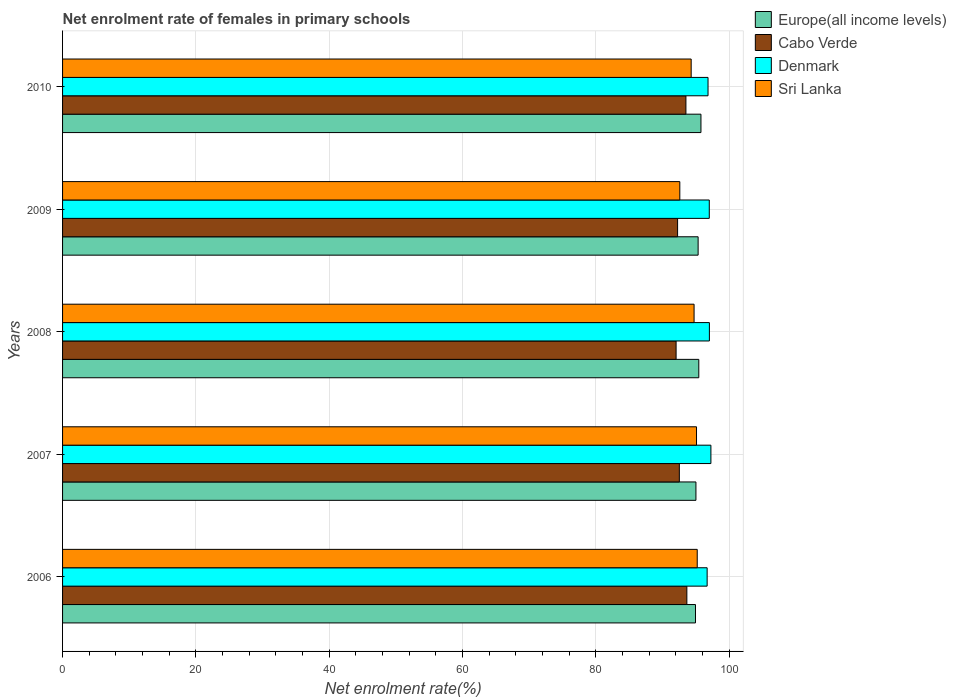Are the number of bars per tick equal to the number of legend labels?
Offer a very short reply. Yes. In how many cases, is the number of bars for a given year not equal to the number of legend labels?
Give a very brief answer. 0. What is the net enrolment rate of females in primary schools in Denmark in 2007?
Make the answer very short. 97.27. Across all years, what is the maximum net enrolment rate of females in primary schools in Sri Lanka?
Offer a terse response. 95.22. Across all years, what is the minimum net enrolment rate of females in primary schools in Sri Lanka?
Provide a succinct answer. 92.61. In which year was the net enrolment rate of females in primary schools in Denmark maximum?
Provide a short and direct response. 2007. What is the total net enrolment rate of females in primary schools in Europe(all income levels) in the graph?
Make the answer very short. 476.56. What is the difference between the net enrolment rate of females in primary schools in Europe(all income levels) in 2008 and that in 2010?
Offer a very short reply. -0.32. What is the difference between the net enrolment rate of females in primary schools in Europe(all income levels) in 2006 and the net enrolment rate of females in primary schools in Denmark in 2010?
Offer a terse response. -1.88. What is the average net enrolment rate of females in primary schools in Europe(all income levels) per year?
Your response must be concise. 95.31. In the year 2006, what is the difference between the net enrolment rate of females in primary schools in Denmark and net enrolment rate of females in primary schools in Sri Lanka?
Your answer should be very brief. 1.49. What is the ratio of the net enrolment rate of females in primary schools in Sri Lanka in 2006 to that in 2008?
Keep it short and to the point. 1.01. Is the net enrolment rate of females in primary schools in Europe(all income levels) in 2007 less than that in 2009?
Your answer should be compact. Yes. What is the difference between the highest and the second highest net enrolment rate of females in primary schools in Europe(all income levels)?
Keep it short and to the point. 0.32. What is the difference between the highest and the lowest net enrolment rate of females in primary schools in Sri Lanka?
Offer a terse response. 2.61. Is the sum of the net enrolment rate of females in primary schools in Denmark in 2006 and 2010 greater than the maximum net enrolment rate of females in primary schools in Europe(all income levels) across all years?
Ensure brevity in your answer.  Yes. What does the 2nd bar from the top in 2006 represents?
Ensure brevity in your answer.  Denmark. What does the 3rd bar from the bottom in 2008 represents?
Give a very brief answer. Denmark. Is it the case that in every year, the sum of the net enrolment rate of females in primary schools in Sri Lanka and net enrolment rate of females in primary schools in Cabo Verde is greater than the net enrolment rate of females in primary schools in Europe(all income levels)?
Ensure brevity in your answer.  Yes. How many years are there in the graph?
Make the answer very short. 5. How many legend labels are there?
Keep it short and to the point. 4. What is the title of the graph?
Provide a short and direct response. Net enrolment rate of females in primary schools. What is the label or title of the X-axis?
Keep it short and to the point. Net enrolment rate(%). What is the Net enrolment rate(%) in Europe(all income levels) in 2006?
Provide a succinct answer. 94.96. What is the Net enrolment rate(%) of Cabo Verde in 2006?
Ensure brevity in your answer.  93.66. What is the Net enrolment rate(%) in Denmark in 2006?
Provide a succinct answer. 96.71. What is the Net enrolment rate(%) in Sri Lanka in 2006?
Offer a terse response. 95.22. What is the Net enrolment rate(%) of Europe(all income levels) in 2007?
Your answer should be compact. 95.02. What is the Net enrolment rate(%) in Cabo Verde in 2007?
Make the answer very short. 92.53. What is the Net enrolment rate(%) in Denmark in 2007?
Your answer should be compact. 97.27. What is the Net enrolment rate(%) in Sri Lanka in 2007?
Your response must be concise. 95.11. What is the Net enrolment rate(%) in Europe(all income levels) in 2008?
Provide a short and direct response. 95.45. What is the Net enrolment rate(%) of Cabo Verde in 2008?
Your answer should be very brief. 92.05. What is the Net enrolment rate(%) in Denmark in 2008?
Your answer should be very brief. 97.04. What is the Net enrolment rate(%) of Sri Lanka in 2008?
Provide a short and direct response. 94.74. What is the Net enrolment rate(%) in Europe(all income levels) in 2009?
Your response must be concise. 95.35. What is the Net enrolment rate(%) of Cabo Verde in 2009?
Your answer should be very brief. 92.27. What is the Net enrolment rate(%) of Denmark in 2009?
Your response must be concise. 97.03. What is the Net enrolment rate(%) in Sri Lanka in 2009?
Offer a terse response. 92.61. What is the Net enrolment rate(%) in Europe(all income levels) in 2010?
Offer a terse response. 95.78. What is the Net enrolment rate(%) of Cabo Verde in 2010?
Ensure brevity in your answer.  93.52. What is the Net enrolment rate(%) of Denmark in 2010?
Offer a terse response. 96.84. What is the Net enrolment rate(%) in Sri Lanka in 2010?
Your answer should be compact. 94.31. Across all years, what is the maximum Net enrolment rate(%) of Europe(all income levels)?
Provide a short and direct response. 95.78. Across all years, what is the maximum Net enrolment rate(%) in Cabo Verde?
Make the answer very short. 93.66. Across all years, what is the maximum Net enrolment rate(%) of Denmark?
Your answer should be compact. 97.27. Across all years, what is the maximum Net enrolment rate(%) in Sri Lanka?
Offer a very short reply. 95.22. Across all years, what is the minimum Net enrolment rate(%) of Europe(all income levels)?
Keep it short and to the point. 94.96. Across all years, what is the minimum Net enrolment rate(%) of Cabo Verde?
Offer a terse response. 92.05. Across all years, what is the minimum Net enrolment rate(%) in Denmark?
Your answer should be compact. 96.71. Across all years, what is the minimum Net enrolment rate(%) in Sri Lanka?
Give a very brief answer. 92.61. What is the total Net enrolment rate(%) of Europe(all income levels) in the graph?
Provide a succinct answer. 476.56. What is the total Net enrolment rate(%) of Cabo Verde in the graph?
Offer a very short reply. 464.04. What is the total Net enrolment rate(%) in Denmark in the graph?
Offer a terse response. 484.89. What is the total Net enrolment rate(%) of Sri Lanka in the graph?
Give a very brief answer. 471.99. What is the difference between the Net enrolment rate(%) of Europe(all income levels) in 2006 and that in 2007?
Provide a short and direct response. -0.07. What is the difference between the Net enrolment rate(%) of Cabo Verde in 2006 and that in 2007?
Provide a short and direct response. 1.13. What is the difference between the Net enrolment rate(%) in Denmark in 2006 and that in 2007?
Your answer should be very brief. -0.56. What is the difference between the Net enrolment rate(%) of Sri Lanka in 2006 and that in 2007?
Give a very brief answer. 0.11. What is the difference between the Net enrolment rate(%) in Europe(all income levels) in 2006 and that in 2008?
Your response must be concise. -0.5. What is the difference between the Net enrolment rate(%) in Cabo Verde in 2006 and that in 2008?
Your answer should be very brief. 1.61. What is the difference between the Net enrolment rate(%) of Denmark in 2006 and that in 2008?
Offer a terse response. -0.34. What is the difference between the Net enrolment rate(%) of Sri Lanka in 2006 and that in 2008?
Provide a short and direct response. 0.47. What is the difference between the Net enrolment rate(%) in Europe(all income levels) in 2006 and that in 2009?
Give a very brief answer. -0.4. What is the difference between the Net enrolment rate(%) of Cabo Verde in 2006 and that in 2009?
Your answer should be compact. 1.39. What is the difference between the Net enrolment rate(%) of Denmark in 2006 and that in 2009?
Your answer should be compact. -0.32. What is the difference between the Net enrolment rate(%) in Sri Lanka in 2006 and that in 2009?
Provide a short and direct response. 2.61. What is the difference between the Net enrolment rate(%) in Europe(all income levels) in 2006 and that in 2010?
Make the answer very short. -0.82. What is the difference between the Net enrolment rate(%) of Cabo Verde in 2006 and that in 2010?
Keep it short and to the point. 0.14. What is the difference between the Net enrolment rate(%) of Denmark in 2006 and that in 2010?
Make the answer very short. -0.13. What is the difference between the Net enrolment rate(%) in Sri Lanka in 2006 and that in 2010?
Your answer should be very brief. 0.91. What is the difference between the Net enrolment rate(%) in Europe(all income levels) in 2007 and that in 2008?
Your answer should be compact. -0.43. What is the difference between the Net enrolment rate(%) of Cabo Verde in 2007 and that in 2008?
Ensure brevity in your answer.  0.49. What is the difference between the Net enrolment rate(%) in Denmark in 2007 and that in 2008?
Offer a very short reply. 0.23. What is the difference between the Net enrolment rate(%) in Sri Lanka in 2007 and that in 2008?
Your answer should be very brief. 0.37. What is the difference between the Net enrolment rate(%) of Europe(all income levels) in 2007 and that in 2009?
Your answer should be compact. -0.33. What is the difference between the Net enrolment rate(%) of Cabo Verde in 2007 and that in 2009?
Your answer should be compact. 0.26. What is the difference between the Net enrolment rate(%) in Denmark in 2007 and that in 2009?
Give a very brief answer. 0.24. What is the difference between the Net enrolment rate(%) in Sri Lanka in 2007 and that in 2009?
Offer a terse response. 2.5. What is the difference between the Net enrolment rate(%) in Europe(all income levels) in 2007 and that in 2010?
Give a very brief answer. -0.75. What is the difference between the Net enrolment rate(%) in Cabo Verde in 2007 and that in 2010?
Your answer should be compact. -0.99. What is the difference between the Net enrolment rate(%) of Denmark in 2007 and that in 2010?
Your response must be concise. 0.43. What is the difference between the Net enrolment rate(%) of Sri Lanka in 2007 and that in 2010?
Offer a terse response. 0.8. What is the difference between the Net enrolment rate(%) of Europe(all income levels) in 2008 and that in 2009?
Provide a succinct answer. 0.1. What is the difference between the Net enrolment rate(%) of Cabo Verde in 2008 and that in 2009?
Ensure brevity in your answer.  -0.23. What is the difference between the Net enrolment rate(%) in Denmark in 2008 and that in 2009?
Provide a short and direct response. 0.02. What is the difference between the Net enrolment rate(%) of Sri Lanka in 2008 and that in 2009?
Ensure brevity in your answer.  2.14. What is the difference between the Net enrolment rate(%) in Europe(all income levels) in 2008 and that in 2010?
Give a very brief answer. -0.32. What is the difference between the Net enrolment rate(%) in Cabo Verde in 2008 and that in 2010?
Give a very brief answer. -1.47. What is the difference between the Net enrolment rate(%) in Denmark in 2008 and that in 2010?
Provide a short and direct response. 0.21. What is the difference between the Net enrolment rate(%) in Sri Lanka in 2008 and that in 2010?
Your answer should be very brief. 0.44. What is the difference between the Net enrolment rate(%) of Europe(all income levels) in 2009 and that in 2010?
Your answer should be very brief. -0.42. What is the difference between the Net enrolment rate(%) in Cabo Verde in 2009 and that in 2010?
Provide a succinct answer. -1.25. What is the difference between the Net enrolment rate(%) of Denmark in 2009 and that in 2010?
Make the answer very short. 0.19. What is the difference between the Net enrolment rate(%) in Sri Lanka in 2009 and that in 2010?
Offer a terse response. -1.7. What is the difference between the Net enrolment rate(%) in Europe(all income levels) in 2006 and the Net enrolment rate(%) in Cabo Verde in 2007?
Ensure brevity in your answer.  2.42. What is the difference between the Net enrolment rate(%) of Europe(all income levels) in 2006 and the Net enrolment rate(%) of Denmark in 2007?
Give a very brief answer. -2.31. What is the difference between the Net enrolment rate(%) of Europe(all income levels) in 2006 and the Net enrolment rate(%) of Sri Lanka in 2007?
Your answer should be very brief. -0.15. What is the difference between the Net enrolment rate(%) of Cabo Verde in 2006 and the Net enrolment rate(%) of Denmark in 2007?
Offer a very short reply. -3.61. What is the difference between the Net enrolment rate(%) of Cabo Verde in 2006 and the Net enrolment rate(%) of Sri Lanka in 2007?
Provide a short and direct response. -1.45. What is the difference between the Net enrolment rate(%) of Denmark in 2006 and the Net enrolment rate(%) of Sri Lanka in 2007?
Your response must be concise. 1.6. What is the difference between the Net enrolment rate(%) of Europe(all income levels) in 2006 and the Net enrolment rate(%) of Cabo Verde in 2008?
Your answer should be compact. 2.91. What is the difference between the Net enrolment rate(%) of Europe(all income levels) in 2006 and the Net enrolment rate(%) of Denmark in 2008?
Offer a very short reply. -2.09. What is the difference between the Net enrolment rate(%) of Europe(all income levels) in 2006 and the Net enrolment rate(%) of Sri Lanka in 2008?
Provide a short and direct response. 0.21. What is the difference between the Net enrolment rate(%) of Cabo Verde in 2006 and the Net enrolment rate(%) of Denmark in 2008?
Keep it short and to the point. -3.38. What is the difference between the Net enrolment rate(%) of Cabo Verde in 2006 and the Net enrolment rate(%) of Sri Lanka in 2008?
Give a very brief answer. -1.08. What is the difference between the Net enrolment rate(%) in Denmark in 2006 and the Net enrolment rate(%) in Sri Lanka in 2008?
Make the answer very short. 1.96. What is the difference between the Net enrolment rate(%) of Europe(all income levels) in 2006 and the Net enrolment rate(%) of Cabo Verde in 2009?
Offer a terse response. 2.68. What is the difference between the Net enrolment rate(%) in Europe(all income levels) in 2006 and the Net enrolment rate(%) in Denmark in 2009?
Ensure brevity in your answer.  -2.07. What is the difference between the Net enrolment rate(%) in Europe(all income levels) in 2006 and the Net enrolment rate(%) in Sri Lanka in 2009?
Your answer should be very brief. 2.35. What is the difference between the Net enrolment rate(%) of Cabo Verde in 2006 and the Net enrolment rate(%) of Denmark in 2009?
Offer a very short reply. -3.36. What is the difference between the Net enrolment rate(%) in Cabo Verde in 2006 and the Net enrolment rate(%) in Sri Lanka in 2009?
Your response must be concise. 1.06. What is the difference between the Net enrolment rate(%) in Denmark in 2006 and the Net enrolment rate(%) in Sri Lanka in 2009?
Ensure brevity in your answer.  4.1. What is the difference between the Net enrolment rate(%) in Europe(all income levels) in 2006 and the Net enrolment rate(%) in Cabo Verde in 2010?
Make the answer very short. 1.43. What is the difference between the Net enrolment rate(%) of Europe(all income levels) in 2006 and the Net enrolment rate(%) of Denmark in 2010?
Provide a short and direct response. -1.88. What is the difference between the Net enrolment rate(%) of Europe(all income levels) in 2006 and the Net enrolment rate(%) of Sri Lanka in 2010?
Provide a short and direct response. 0.65. What is the difference between the Net enrolment rate(%) in Cabo Verde in 2006 and the Net enrolment rate(%) in Denmark in 2010?
Ensure brevity in your answer.  -3.18. What is the difference between the Net enrolment rate(%) in Cabo Verde in 2006 and the Net enrolment rate(%) in Sri Lanka in 2010?
Your response must be concise. -0.65. What is the difference between the Net enrolment rate(%) in Denmark in 2006 and the Net enrolment rate(%) in Sri Lanka in 2010?
Offer a terse response. 2.4. What is the difference between the Net enrolment rate(%) in Europe(all income levels) in 2007 and the Net enrolment rate(%) in Cabo Verde in 2008?
Make the answer very short. 2.98. What is the difference between the Net enrolment rate(%) of Europe(all income levels) in 2007 and the Net enrolment rate(%) of Denmark in 2008?
Keep it short and to the point. -2.02. What is the difference between the Net enrolment rate(%) in Europe(all income levels) in 2007 and the Net enrolment rate(%) in Sri Lanka in 2008?
Offer a very short reply. 0.28. What is the difference between the Net enrolment rate(%) in Cabo Verde in 2007 and the Net enrolment rate(%) in Denmark in 2008?
Offer a terse response. -4.51. What is the difference between the Net enrolment rate(%) of Cabo Verde in 2007 and the Net enrolment rate(%) of Sri Lanka in 2008?
Offer a terse response. -2.21. What is the difference between the Net enrolment rate(%) in Denmark in 2007 and the Net enrolment rate(%) in Sri Lanka in 2008?
Make the answer very short. 2.53. What is the difference between the Net enrolment rate(%) of Europe(all income levels) in 2007 and the Net enrolment rate(%) of Cabo Verde in 2009?
Offer a terse response. 2.75. What is the difference between the Net enrolment rate(%) of Europe(all income levels) in 2007 and the Net enrolment rate(%) of Denmark in 2009?
Give a very brief answer. -2. What is the difference between the Net enrolment rate(%) of Europe(all income levels) in 2007 and the Net enrolment rate(%) of Sri Lanka in 2009?
Give a very brief answer. 2.42. What is the difference between the Net enrolment rate(%) in Cabo Verde in 2007 and the Net enrolment rate(%) in Denmark in 2009?
Your answer should be compact. -4.49. What is the difference between the Net enrolment rate(%) in Cabo Verde in 2007 and the Net enrolment rate(%) in Sri Lanka in 2009?
Offer a terse response. -0.07. What is the difference between the Net enrolment rate(%) of Denmark in 2007 and the Net enrolment rate(%) of Sri Lanka in 2009?
Make the answer very short. 4.66. What is the difference between the Net enrolment rate(%) in Europe(all income levels) in 2007 and the Net enrolment rate(%) in Cabo Verde in 2010?
Keep it short and to the point. 1.5. What is the difference between the Net enrolment rate(%) of Europe(all income levels) in 2007 and the Net enrolment rate(%) of Denmark in 2010?
Make the answer very short. -1.81. What is the difference between the Net enrolment rate(%) of Europe(all income levels) in 2007 and the Net enrolment rate(%) of Sri Lanka in 2010?
Provide a succinct answer. 0.71. What is the difference between the Net enrolment rate(%) of Cabo Verde in 2007 and the Net enrolment rate(%) of Denmark in 2010?
Make the answer very short. -4.3. What is the difference between the Net enrolment rate(%) in Cabo Verde in 2007 and the Net enrolment rate(%) in Sri Lanka in 2010?
Offer a very short reply. -1.77. What is the difference between the Net enrolment rate(%) in Denmark in 2007 and the Net enrolment rate(%) in Sri Lanka in 2010?
Provide a succinct answer. 2.96. What is the difference between the Net enrolment rate(%) of Europe(all income levels) in 2008 and the Net enrolment rate(%) of Cabo Verde in 2009?
Provide a succinct answer. 3.18. What is the difference between the Net enrolment rate(%) in Europe(all income levels) in 2008 and the Net enrolment rate(%) in Denmark in 2009?
Provide a short and direct response. -1.57. What is the difference between the Net enrolment rate(%) in Europe(all income levels) in 2008 and the Net enrolment rate(%) in Sri Lanka in 2009?
Make the answer very short. 2.85. What is the difference between the Net enrolment rate(%) in Cabo Verde in 2008 and the Net enrolment rate(%) in Denmark in 2009?
Your response must be concise. -4.98. What is the difference between the Net enrolment rate(%) of Cabo Verde in 2008 and the Net enrolment rate(%) of Sri Lanka in 2009?
Provide a succinct answer. -0.56. What is the difference between the Net enrolment rate(%) of Denmark in 2008 and the Net enrolment rate(%) of Sri Lanka in 2009?
Offer a terse response. 4.44. What is the difference between the Net enrolment rate(%) of Europe(all income levels) in 2008 and the Net enrolment rate(%) of Cabo Verde in 2010?
Your response must be concise. 1.93. What is the difference between the Net enrolment rate(%) in Europe(all income levels) in 2008 and the Net enrolment rate(%) in Denmark in 2010?
Offer a very short reply. -1.39. What is the difference between the Net enrolment rate(%) in Europe(all income levels) in 2008 and the Net enrolment rate(%) in Sri Lanka in 2010?
Your answer should be very brief. 1.14. What is the difference between the Net enrolment rate(%) in Cabo Verde in 2008 and the Net enrolment rate(%) in Denmark in 2010?
Your answer should be very brief. -4.79. What is the difference between the Net enrolment rate(%) of Cabo Verde in 2008 and the Net enrolment rate(%) of Sri Lanka in 2010?
Keep it short and to the point. -2.26. What is the difference between the Net enrolment rate(%) in Denmark in 2008 and the Net enrolment rate(%) in Sri Lanka in 2010?
Offer a terse response. 2.73. What is the difference between the Net enrolment rate(%) of Europe(all income levels) in 2009 and the Net enrolment rate(%) of Cabo Verde in 2010?
Ensure brevity in your answer.  1.83. What is the difference between the Net enrolment rate(%) of Europe(all income levels) in 2009 and the Net enrolment rate(%) of Denmark in 2010?
Make the answer very short. -1.49. What is the difference between the Net enrolment rate(%) of Europe(all income levels) in 2009 and the Net enrolment rate(%) of Sri Lanka in 2010?
Offer a terse response. 1.04. What is the difference between the Net enrolment rate(%) in Cabo Verde in 2009 and the Net enrolment rate(%) in Denmark in 2010?
Offer a terse response. -4.57. What is the difference between the Net enrolment rate(%) in Cabo Verde in 2009 and the Net enrolment rate(%) in Sri Lanka in 2010?
Give a very brief answer. -2.04. What is the difference between the Net enrolment rate(%) of Denmark in 2009 and the Net enrolment rate(%) of Sri Lanka in 2010?
Offer a very short reply. 2.72. What is the average Net enrolment rate(%) of Europe(all income levels) per year?
Your response must be concise. 95.31. What is the average Net enrolment rate(%) in Cabo Verde per year?
Provide a short and direct response. 92.81. What is the average Net enrolment rate(%) of Denmark per year?
Offer a very short reply. 96.98. What is the average Net enrolment rate(%) in Sri Lanka per year?
Provide a succinct answer. 94.4. In the year 2006, what is the difference between the Net enrolment rate(%) in Europe(all income levels) and Net enrolment rate(%) in Cabo Verde?
Your response must be concise. 1.29. In the year 2006, what is the difference between the Net enrolment rate(%) in Europe(all income levels) and Net enrolment rate(%) in Denmark?
Make the answer very short. -1.75. In the year 2006, what is the difference between the Net enrolment rate(%) in Europe(all income levels) and Net enrolment rate(%) in Sri Lanka?
Offer a terse response. -0.26. In the year 2006, what is the difference between the Net enrolment rate(%) in Cabo Verde and Net enrolment rate(%) in Denmark?
Offer a very short reply. -3.04. In the year 2006, what is the difference between the Net enrolment rate(%) of Cabo Verde and Net enrolment rate(%) of Sri Lanka?
Offer a very short reply. -1.56. In the year 2006, what is the difference between the Net enrolment rate(%) in Denmark and Net enrolment rate(%) in Sri Lanka?
Your answer should be very brief. 1.49. In the year 2007, what is the difference between the Net enrolment rate(%) of Europe(all income levels) and Net enrolment rate(%) of Cabo Verde?
Make the answer very short. 2.49. In the year 2007, what is the difference between the Net enrolment rate(%) of Europe(all income levels) and Net enrolment rate(%) of Denmark?
Offer a very short reply. -2.25. In the year 2007, what is the difference between the Net enrolment rate(%) in Europe(all income levels) and Net enrolment rate(%) in Sri Lanka?
Provide a succinct answer. -0.09. In the year 2007, what is the difference between the Net enrolment rate(%) in Cabo Verde and Net enrolment rate(%) in Denmark?
Make the answer very short. -4.74. In the year 2007, what is the difference between the Net enrolment rate(%) of Cabo Verde and Net enrolment rate(%) of Sri Lanka?
Keep it short and to the point. -2.58. In the year 2007, what is the difference between the Net enrolment rate(%) in Denmark and Net enrolment rate(%) in Sri Lanka?
Your response must be concise. 2.16. In the year 2008, what is the difference between the Net enrolment rate(%) of Europe(all income levels) and Net enrolment rate(%) of Cabo Verde?
Your answer should be compact. 3.41. In the year 2008, what is the difference between the Net enrolment rate(%) in Europe(all income levels) and Net enrolment rate(%) in Denmark?
Give a very brief answer. -1.59. In the year 2008, what is the difference between the Net enrolment rate(%) of Europe(all income levels) and Net enrolment rate(%) of Sri Lanka?
Offer a terse response. 0.71. In the year 2008, what is the difference between the Net enrolment rate(%) in Cabo Verde and Net enrolment rate(%) in Denmark?
Your answer should be very brief. -5. In the year 2008, what is the difference between the Net enrolment rate(%) of Cabo Verde and Net enrolment rate(%) of Sri Lanka?
Your response must be concise. -2.7. In the year 2008, what is the difference between the Net enrolment rate(%) in Denmark and Net enrolment rate(%) in Sri Lanka?
Ensure brevity in your answer.  2.3. In the year 2009, what is the difference between the Net enrolment rate(%) of Europe(all income levels) and Net enrolment rate(%) of Cabo Verde?
Keep it short and to the point. 3.08. In the year 2009, what is the difference between the Net enrolment rate(%) of Europe(all income levels) and Net enrolment rate(%) of Denmark?
Make the answer very short. -1.67. In the year 2009, what is the difference between the Net enrolment rate(%) in Europe(all income levels) and Net enrolment rate(%) in Sri Lanka?
Offer a terse response. 2.75. In the year 2009, what is the difference between the Net enrolment rate(%) of Cabo Verde and Net enrolment rate(%) of Denmark?
Your answer should be very brief. -4.75. In the year 2009, what is the difference between the Net enrolment rate(%) in Cabo Verde and Net enrolment rate(%) in Sri Lanka?
Your answer should be very brief. -0.33. In the year 2009, what is the difference between the Net enrolment rate(%) in Denmark and Net enrolment rate(%) in Sri Lanka?
Your answer should be compact. 4.42. In the year 2010, what is the difference between the Net enrolment rate(%) in Europe(all income levels) and Net enrolment rate(%) in Cabo Verde?
Keep it short and to the point. 2.25. In the year 2010, what is the difference between the Net enrolment rate(%) of Europe(all income levels) and Net enrolment rate(%) of Denmark?
Offer a very short reply. -1.06. In the year 2010, what is the difference between the Net enrolment rate(%) in Europe(all income levels) and Net enrolment rate(%) in Sri Lanka?
Provide a succinct answer. 1.47. In the year 2010, what is the difference between the Net enrolment rate(%) of Cabo Verde and Net enrolment rate(%) of Denmark?
Offer a very short reply. -3.32. In the year 2010, what is the difference between the Net enrolment rate(%) of Cabo Verde and Net enrolment rate(%) of Sri Lanka?
Offer a terse response. -0.79. In the year 2010, what is the difference between the Net enrolment rate(%) of Denmark and Net enrolment rate(%) of Sri Lanka?
Offer a very short reply. 2.53. What is the ratio of the Net enrolment rate(%) in Cabo Verde in 2006 to that in 2007?
Make the answer very short. 1.01. What is the ratio of the Net enrolment rate(%) of Cabo Verde in 2006 to that in 2008?
Your response must be concise. 1.02. What is the ratio of the Net enrolment rate(%) in Cabo Verde in 2006 to that in 2009?
Your answer should be compact. 1.02. What is the ratio of the Net enrolment rate(%) of Sri Lanka in 2006 to that in 2009?
Offer a terse response. 1.03. What is the ratio of the Net enrolment rate(%) in Cabo Verde in 2006 to that in 2010?
Make the answer very short. 1. What is the ratio of the Net enrolment rate(%) of Sri Lanka in 2006 to that in 2010?
Provide a succinct answer. 1.01. What is the ratio of the Net enrolment rate(%) of Cabo Verde in 2007 to that in 2008?
Ensure brevity in your answer.  1.01. What is the ratio of the Net enrolment rate(%) in Denmark in 2007 to that in 2008?
Give a very brief answer. 1. What is the ratio of the Net enrolment rate(%) of Europe(all income levels) in 2007 to that in 2009?
Your response must be concise. 1. What is the ratio of the Net enrolment rate(%) of Cabo Verde in 2007 to that in 2009?
Your answer should be compact. 1. What is the ratio of the Net enrolment rate(%) in Denmark in 2007 to that in 2009?
Your answer should be compact. 1. What is the ratio of the Net enrolment rate(%) in Sri Lanka in 2007 to that in 2009?
Your answer should be very brief. 1.03. What is the ratio of the Net enrolment rate(%) in Sri Lanka in 2007 to that in 2010?
Make the answer very short. 1.01. What is the ratio of the Net enrolment rate(%) in Sri Lanka in 2008 to that in 2009?
Keep it short and to the point. 1.02. What is the ratio of the Net enrolment rate(%) in Cabo Verde in 2008 to that in 2010?
Your answer should be compact. 0.98. What is the ratio of the Net enrolment rate(%) of Cabo Verde in 2009 to that in 2010?
Your answer should be compact. 0.99. What is the ratio of the Net enrolment rate(%) of Denmark in 2009 to that in 2010?
Provide a succinct answer. 1. What is the ratio of the Net enrolment rate(%) in Sri Lanka in 2009 to that in 2010?
Give a very brief answer. 0.98. What is the difference between the highest and the second highest Net enrolment rate(%) in Europe(all income levels)?
Ensure brevity in your answer.  0.32. What is the difference between the highest and the second highest Net enrolment rate(%) in Cabo Verde?
Keep it short and to the point. 0.14. What is the difference between the highest and the second highest Net enrolment rate(%) in Denmark?
Your response must be concise. 0.23. What is the difference between the highest and the second highest Net enrolment rate(%) of Sri Lanka?
Your response must be concise. 0.11. What is the difference between the highest and the lowest Net enrolment rate(%) of Europe(all income levels)?
Offer a terse response. 0.82. What is the difference between the highest and the lowest Net enrolment rate(%) in Cabo Verde?
Offer a terse response. 1.61. What is the difference between the highest and the lowest Net enrolment rate(%) of Denmark?
Provide a succinct answer. 0.56. What is the difference between the highest and the lowest Net enrolment rate(%) in Sri Lanka?
Your answer should be compact. 2.61. 